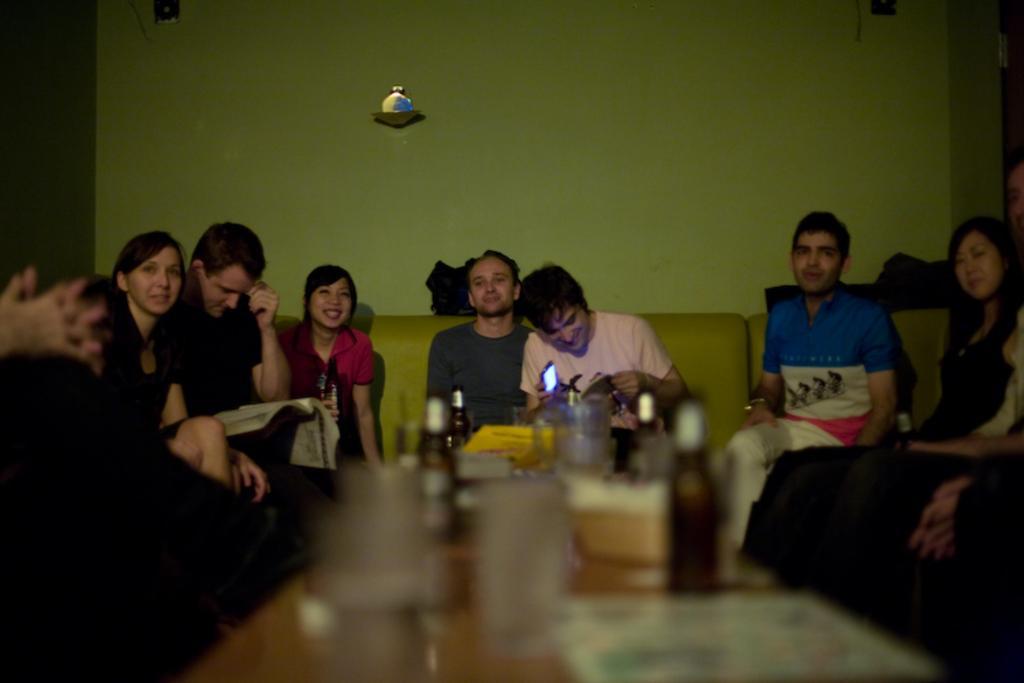Describe this image in one or two sentences. In this picture there are group of people sitting on the sofa. In the foreground there are glasses and bottles and papers on the table. At the back there are objects on the wall and there is a man sitting and holding the book and there is a man sitting and holding the device. 